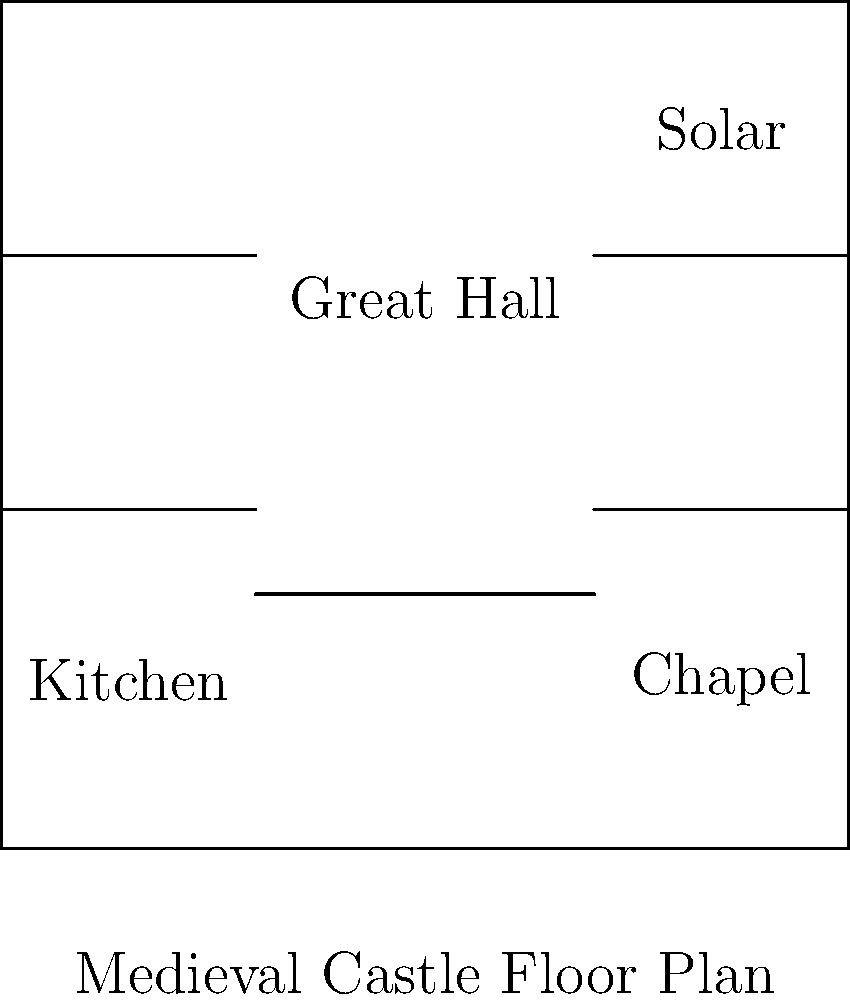Analyze the floor plan of this medieval castle. Which architectural feature is most prominently represented, and how does it reflect the social and defensive functions of castles during this historical period? To answer this question, let's analyze the floor plan step-by-step:

1. Identify the main components:
   - A large central space (Great Hall)
   - Smaller rooms surrounding the central space
   - Thick outer walls

2. Recognize the prominent feature:
   The Great Hall is the largest and most central room, occupying a significant portion of the floor plan.

3. Understand the functions of the Great Hall:
   a) Social function:
      - Served as a gathering place for the lord, family, and guests
      - Used for feasts, ceremonies, and entertainment
      - Demonstrated the lord's power and wealth
   b) Administrative function:
      - Used for holding court and conducting business
   c) Defensive function:
      - Central location allowed quick access to other parts of the castle
      - Could serve as a last line of defense if outer walls were breached

4. Analyze how the Great Hall reflects medieval castle design:
   - Central location emphasizes its importance in daily castle life
   - Large size accommodates many people, supporting its social functions
   - Proximity to other rooms (kitchen, solar, chapel) shows its role as the heart of castle activities

5. Consider the historical context:
   - Medieval castles were centers of feudal power and administration
   - They needed to balance defensive capabilities with comfortable living spaces for nobility

The prominence of the Great Hall in this floor plan reflects the dual nature of medieval castles as both defensive structures and centers of social and political life.
Answer: The Great Hall, reflecting castles' social and defensive functions. 